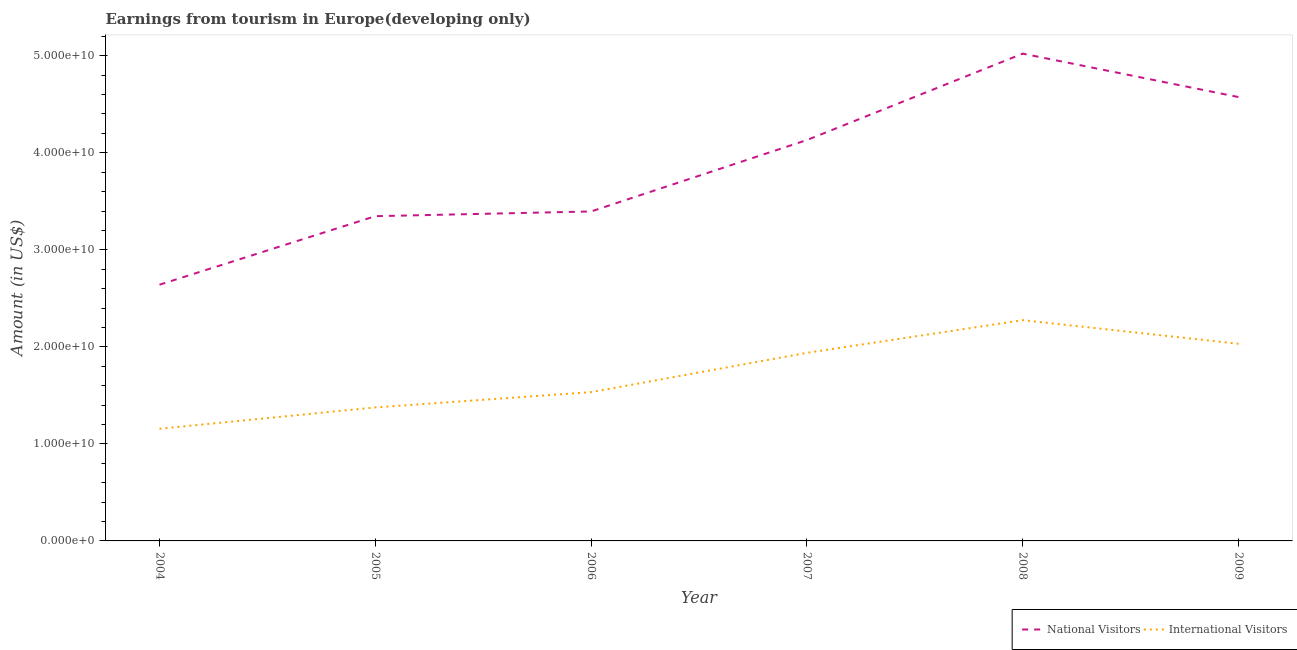How many different coloured lines are there?
Offer a terse response. 2. What is the amount earned from national visitors in 2007?
Provide a succinct answer. 4.13e+1. Across all years, what is the maximum amount earned from international visitors?
Your response must be concise. 2.28e+1. Across all years, what is the minimum amount earned from national visitors?
Provide a short and direct response. 2.64e+1. What is the total amount earned from international visitors in the graph?
Provide a short and direct response. 1.03e+11. What is the difference between the amount earned from international visitors in 2005 and that in 2006?
Offer a terse response. -1.58e+09. What is the difference between the amount earned from national visitors in 2006 and the amount earned from international visitors in 2009?
Provide a succinct answer. 1.36e+1. What is the average amount earned from international visitors per year?
Ensure brevity in your answer.  1.72e+1. In the year 2004, what is the difference between the amount earned from international visitors and amount earned from national visitors?
Provide a succinct answer. -1.48e+1. In how many years, is the amount earned from international visitors greater than 20000000000 US$?
Your answer should be very brief. 2. What is the ratio of the amount earned from national visitors in 2007 to that in 2008?
Provide a short and direct response. 0.82. What is the difference between the highest and the second highest amount earned from international visitors?
Keep it short and to the point. 2.44e+09. What is the difference between the highest and the lowest amount earned from international visitors?
Offer a very short reply. 1.12e+1. In how many years, is the amount earned from international visitors greater than the average amount earned from international visitors taken over all years?
Ensure brevity in your answer.  3. Does the amount earned from international visitors monotonically increase over the years?
Offer a terse response. No. Is the amount earned from national visitors strictly less than the amount earned from international visitors over the years?
Offer a very short reply. No. How many lines are there?
Keep it short and to the point. 2. How many years are there in the graph?
Provide a succinct answer. 6. Does the graph contain any zero values?
Your response must be concise. No. How many legend labels are there?
Your answer should be compact. 2. What is the title of the graph?
Give a very brief answer. Earnings from tourism in Europe(developing only). What is the Amount (in US$) in National Visitors in 2004?
Provide a short and direct response. 2.64e+1. What is the Amount (in US$) in International Visitors in 2004?
Give a very brief answer. 1.16e+1. What is the Amount (in US$) in National Visitors in 2005?
Your answer should be compact. 3.35e+1. What is the Amount (in US$) in International Visitors in 2005?
Offer a very short reply. 1.38e+1. What is the Amount (in US$) of National Visitors in 2006?
Provide a succinct answer. 3.40e+1. What is the Amount (in US$) of International Visitors in 2006?
Offer a terse response. 1.53e+1. What is the Amount (in US$) of National Visitors in 2007?
Offer a terse response. 4.13e+1. What is the Amount (in US$) of International Visitors in 2007?
Your answer should be compact. 1.94e+1. What is the Amount (in US$) in National Visitors in 2008?
Your answer should be compact. 5.02e+1. What is the Amount (in US$) of International Visitors in 2008?
Your answer should be very brief. 2.28e+1. What is the Amount (in US$) in National Visitors in 2009?
Provide a succinct answer. 4.57e+1. What is the Amount (in US$) in International Visitors in 2009?
Keep it short and to the point. 2.03e+1. Across all years, what is the maximum Amount (in US$) in National Visitors?
Keep it short and to the point. 5.02e+1. Across all years, what is the maximum Amount (in US$) in International Visitors?
Provide a short and direct response. 2.28e+1. Across all years, what is the minimum Amount (in US$) of National Visitors?
Provide a succinct answer. 2.64e+1. Across all years, what is the minimum Amount (in US$) of International Visitors?
Keep it short and to the point. 1.16e+1. What is the total Amount (in US$) in National Visitors in the graph?
Your answer should be very brief. 2.31e+11. What is the total Amount (in US$) of International Visitors in the graph?
Keep it short and to the point. 1.03e+11. What is the difference between the Amount (in US$) of National Visitors in 2004 and that in 2005?
Keep it short and to the point. -7.06e+09. What is the difference between the Amount (in US$) of International Visitors in 2004 and that in 2005?
Provide a short and direct response. -2.20e+09. What is the difference between the Amount (in US$) in National Visitors in 2004 and that in 2006?
Make the answer very short. -7.55e+09. What is the difference between the Amount (in US$) in International Visitors in 2004 and that in 2006?
Your answer should be compact. -3.78e+09. What is the difference between the Amount (in US$) of National Visitors in 2004 and that in 2007?
Ensure brevity in your answer.  -1.49e+1. What is the difference between the Amount (in US$) of International Visitors in 2004 and that in 2007?
Provide a succinct answer. -7.83e+09. What is the difference between the Amount (in US$) of National Visitors in 2004 and that in 2008?
Provide a short and direct response. -2.38e+1. What is the difference between the Amount (in US$) in International Visitors in 2004 and that in 2008?
Provide a succinct answer. -1.12e+1. What is the difference between the Amount (in US$) of National Visitors in 2004 and that in 2009?
Provide a short and direct response. -1.93e+1. What is the difference between the Amount (in US$) in International Visitors in 2004 and that in 2009?
Your answer should be compact. -8.76e+09. What is the difference between the Amount (in US$) in National Visitors in 2005 and that in 2006?
Provide a short and direct response. -4.89e+08. What is the difference between the Amount (in US$) in International Visitors in 2005 and that in 2006?
Offer a very short reply. -1.58e+09. What is the difference between the Amount (in US$) of National Visitors in 2005 and that in 2007?
Make the answer very short. -7.85e+09. What is the difference between the Amount (in US$) in International Visitors in 2005 and that in 2007?
Your answer should be very brief. -5.63e+09. What is the difference between the Amount (in US$) in National Visitors in 2005 and that in 2008?
Your answer should be compact. -1.68e+1. What is the difference between the Amount (in US$) in International Visitors in 2005 and that in 2008?
Provide a short and direct response. -9.00e+09. What is the difference between the Amount (in US$) of National Visitors in 2005 and that in 2009?
Your answer should be compact. -1.23e+1. What is the difference between the Amount (in US$) of International Visitors in 2005 and that in 2009?
Your response must be concise. -6.56e+09. What is the difference between the Amount (in US$) in National Visitors in 2006 and that in 2007?
Provide a short and direct response. -7.36e+09. What is the difference between the Amount (in US$) in International Visitors in 2006 and that in 2007?
Make the answer very short. -4.05e+09. What is the difference between the Amount (in US$) of National Visitors in 2006 and that in 2008?
Your answer should be compact. -1.63e+1. What is the difference between the Amount (in US$) in International Visitors in 2006 and that in 2008?
Give a very brief answer. -7.42e+09. What is the difference between the Amount (in US$) of National Visitors in 2006 and that in 2009?
Offer a very short reply. -1.18e+1. What is the difference between the Amount (in US$) in International Visitors in 2006 and that in 2009?
Make the answer very short. -4.98e+09. What is the difference between the Amount (in US$) in National Visitors in 2007 and that in 2008?
Offer a very short reply. -8.91e+09. What is the difference between the Amount (in US$) in International Visitors in 2007 and that in 2008?
Provide a short and direct response. -3.37e+09. What is the difference between the Amount (in US$) of National Visitors in 2007 and that in 2009?
Offer a terse response. -4.43e+09. What is the difference between the Amount (in US$) in International Visitors in 2007 and that in 2009?
Provide a succinct answer. -9.32e+08. What is the difference between the Amount (in US$) of National Visitors in 2008 and that in 2009?
Your response must be concise. 4.48e+09. What is the difference between the Amount (in US$) of International Visitors in 2008 and that in 2009?
Ensure brevity in your answer.  2.44e+09. What is the difference between the Amount (in US$) of National Visitors in 2004 and the Amount (in US$) of International Visitors in 2005?
Keep it short and to the point. 1.26e+1. What is the difference between the Amount (in US$) in National Visitors in 2004 and the Amount (in US$) in International Visitors in 2006?
Your answer should be very brief. 1.11e+1. What is the difference between the Amount (in US$) of National Visitors in 2004 and the Amount (in US$) of International Visitors in 2007?
Your response must be concise. 7.02e+09. What is the difference between the Amount (in US$) in National Visitors in 2004 and the Amount (in US$) in International Visitors in 2008?
Ensure brevity in your answer.  3.65e+09. What is the difference between the Amount (in US$) of National Visitors in 2004 and the Amount (in US$) of International Visitors in 2009?
Your answer should be very brief. 6.09e+09. What is the difference between the Amount (in US$) of National Visitors in 2005 and the Amount (in US$) of International Visitors in 2006?
Provide a succinct answer. 1.81e+1. What is the difference between the Amount (in US$) in National Visitors in 2005 and the Amount (in US$) in International Visitors in 2007?
Your answer should be very brief. 1.41e+1. What is the difference between the Amount (in US$) of National Visitors in 2005 and the Amount (in US$) of International Visitors in 2008?
Offer a terse response. 1.07e+1. What is the difference between the Amount (in US$) in National Visitors in 2005 and the Amount (in US$) in International Visitors in 2009?
Ensure brevity in your answer.  1.32e+1. What is the difference between the Amount (in US$) in National Visitors in 2006 and the Amount (in US$) in International Visitors in 2007?
Offer a terse response. 1.46e+1. What is the difference between the Amount (in US$) of National Visitors in 2006 and the Amount (in US$) of International Visitors in 2008?
Your answer should be compact. 1.12e+1. What is the difference between the Amount (in US$) in National Visitors in 2006 and the Amount (in US$) in International Visitors in 2009?
Your answer should be very brief. 1.36e+1. What is the difference between the Amount (in US$) of National Visitors in 2007 and the Amount (in US$) of International Visitors in 2008?
Your answer should be compact. 1.86e+1. What is the difference between the Amount (in US$) of National Visitors in 2007 and the Amount (in US$) of International Visitors in 2009?
Make the answer very short. 2.10e+1. What is the difference between the Amount (in US$) of National Visitors in 2008 and the Amount (in US$) of International Visitors in 2009?
Provide a short and direct response. 2.99e+1. What is the average Amount (in US$) of National Visitors per year?
Ensure brevity in your answer.  3.85e+1. What is the average Amount (in US$) in International Visitors per year?
Ensure brevity in your answer.  1.72e+1. In the year 2004, what is the difference between the Amount (in US$) of National Visitors and Amount (in US$) of International Visitors?
Offer a terse response. 1.48e+1. In the year 2005, what is the difference between the Amount (in US$) in National Visitors and Amount (in US$) in International Visitors?
Provide a short and direct response. 1.97e+1. In the year 2006, what is the difference between the Amount (in US$) of National Visitors and Amount (in US$) of International Visitors?
Make the answer very short. 1.86e+1. In the year 2007, what is the difference between the Amount (in US$) of National Visitors and Amount (in US$) of International Visitors?
Your response must be concise. 2.19e+1. In the year 2008, what is the difference between the Amount (in US$) of National Visitors and Amount (in US$) of International Visitors?
Ensure brevity in your answer.  2.75e+1. In the year 2009, what is the difference between the Amount (in US$) in National Visitors and Amount (in US$) in International Visitors?
Provide a succinct answer. 2.54e+1. What is the ratio of the Amount (in US$) in National Visitors in 2004 to that in 2005?
Make the answer very short. 0.79. What is the ratio of the Amount (in US$) of International Visitors in 2004 to that in 2005?
Give a very brief answer. 0.84. What is the ratio of the Amount (in US$) of National Visitors in 2004 to that in 2006?
Offer a very short reply. 0.78. What is the ratio of the Amount (in US$) in International Visitors in 2004 to that in 2006?
Keep it short and to the point. 0.75. What is the ratio of the Amount (in US$) of National Visitors in 2004 to that in 2007?
Offer a terse response. 0.64. What is the ratio of the Amount (in US$) in International Visitors in 2004 to that in 2007?
Make the answer very short. 0.6. What is the ratio of the Amount (in US$) of National Visitors in 2004 to that in 2008?
Keep it short and to the point. 0.53. What is the ratio of the Amount (in US$) of International Visitors in 2004 to that in 2008?
Your response must be concise. 0.51. What is the ratio of the Amount (in US$) of National Visitors in 2004 to that in 2009?
Give a very brief answer. 0.58. What is the ratio of the Amount (in US$) in International Visitors in 2004 to that in 2009?
Ensure brevity in your answer.  0.57. What is the ratio of the Amount (in US$) of National Visitors in 2005 to that in 2006?
Your answer should be compact. 0.99. What is the ratio of the Amount (in US$) in International Visitors in 2005 to that in 2006?
Provide a succinct answer. 0.9. What is the ratio of the Amount (in US$) in National Visitors in 2005 to that in 2007?
Provide a short and direct response. 0.81. What is the ratio of the Amount (in US$) in International Visitors in 2005 to that in 2007?
Offer a very short reply. 0.71. What is the ratio of the Amount (in US$) of National Visitors in 2005 to that in 2008?
Ensure brevity in your answer.  0.67. What is the ratio of the Amount (in US$) of International Visitors in 2005 to that in 2008?
Offer a terse response. 0.6. What is the ratio of the Amount (in US$) in National Visitors in 2005 to that in 2009?
Provide a short and direct response. 0.73. What is the ratio of the Amount (in US$) in International Visitors in 2005 to that in 2009?
Provide a succinct answer. 0.68. What is the ratio of the Amount (in US$) of National Visitors in 2006 to that in 2007?
Offer a terse response. 0.82. What is the ratio of the Amount (in US$) in International Visitors in 2006 to that in 2007?
Offer a very short reply. 0.79. What is the ratio of the Amount (in US$) of National Visitors in 2006 to that in 2008?
Provide a succinct answer. 0.68. What is the ratio of the Amount (in US$) of International Visitors in 2006 to that in 2008?
Make the answer very short. 0.67. What is the ratio of the Amount (in US$) of National Visitors in 2006 to that in 2009?
Keep it short and to the point. 0.74. What is the ratio of the Amount (in US$) of International Visitors in 2006 to that in 2009?
Ensure brevity in your answer.  0.75. What is the ratio of the Amount (in US$) in National Visitors in 2007 to that in 2008?
Your answer should be very brief. 0.82. What is the ratio of the Amount (in US$) of International Visitors in 2007 to that in 2008?
Ensure brevity in your answer.  0.85. What is the ratio of the Amount (in US$) of National Visitors in 2007 to that in 2009?
Keep it short and to the point. 0.9. What is the ratio of the Amount (in US$) in International Visitors in 2007 to that in 2009?
Provide a short and direct response. 0.95. What is the ratio of the Amount (in US$) in National Visitors in 2008 to that in 2009?
Ensure brevity in your answer.  1.1. What is the ratio of the Amount (in US$) in International Visitors in 2008 to that in 2009?
Ensure brevity in your answer.  1.12. What is the difference between the highest and the second highest Amount (in US$) in National Visitors?
Ensure brevity in your answer.  4.48e+09. What is the difference between the highest and the second highest Amount (in US$) in International Visitors?
Make the answer very short. 2.44e+09. What is the difference between the highest and the lowest Amount (in US$) in National Visitors?
Give a very brief answer. 2.38e+1. What is the difference between the highest and the lowest Amount (in US$) of International Visitors?
Keep it short and to the point. 1.12e+1. 